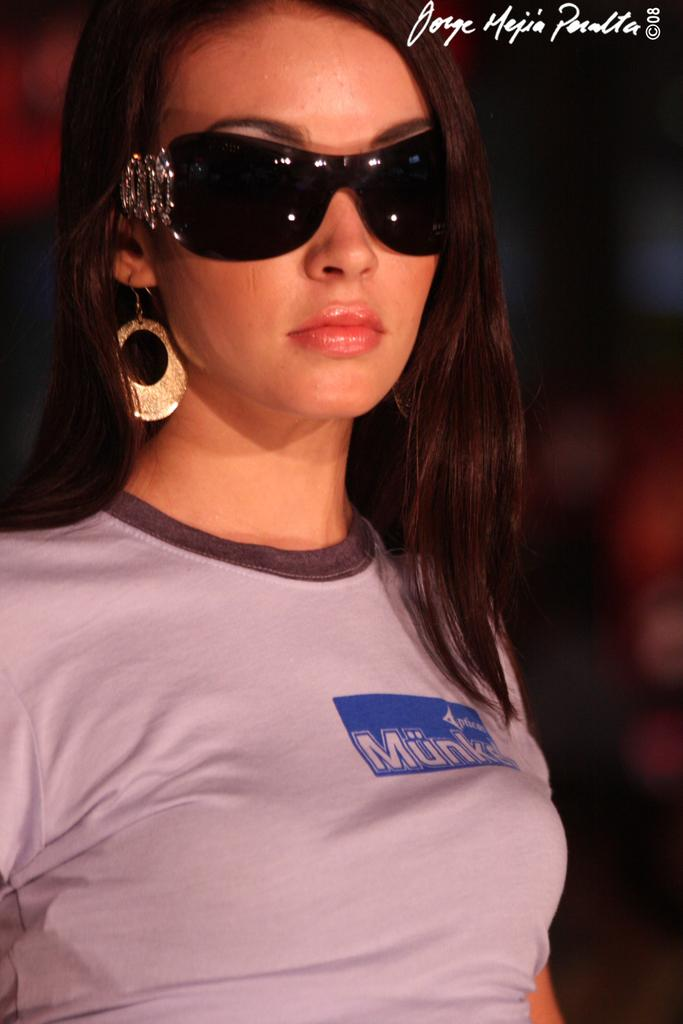Who is the main subject in the image? There is a woman in the image. What accessory is the woman wearing? The woman is wearing glasses. Can you describe the background of the image? The background of the image is blurred. What else can be seen in the image besides the woman? There is text visible in the image. What type of meal is the woman preparing in the image? There is no meal preparation visible in the image; the woman is not shown cooking or preparing food. 